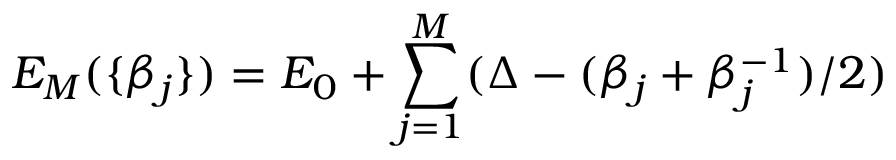Convert formula to latex. <formula><loc_0><loc_0><loc_500><loc_500>E _ { M } ( \{ \beta _ { j } \} ) = E _ { 0 } + \sum _ { j = 1 } ^ { M } ( \Delta - ( \beta _ { j } + \beta _ { j } ^ { - 1 } ) / 2 )</formula> 